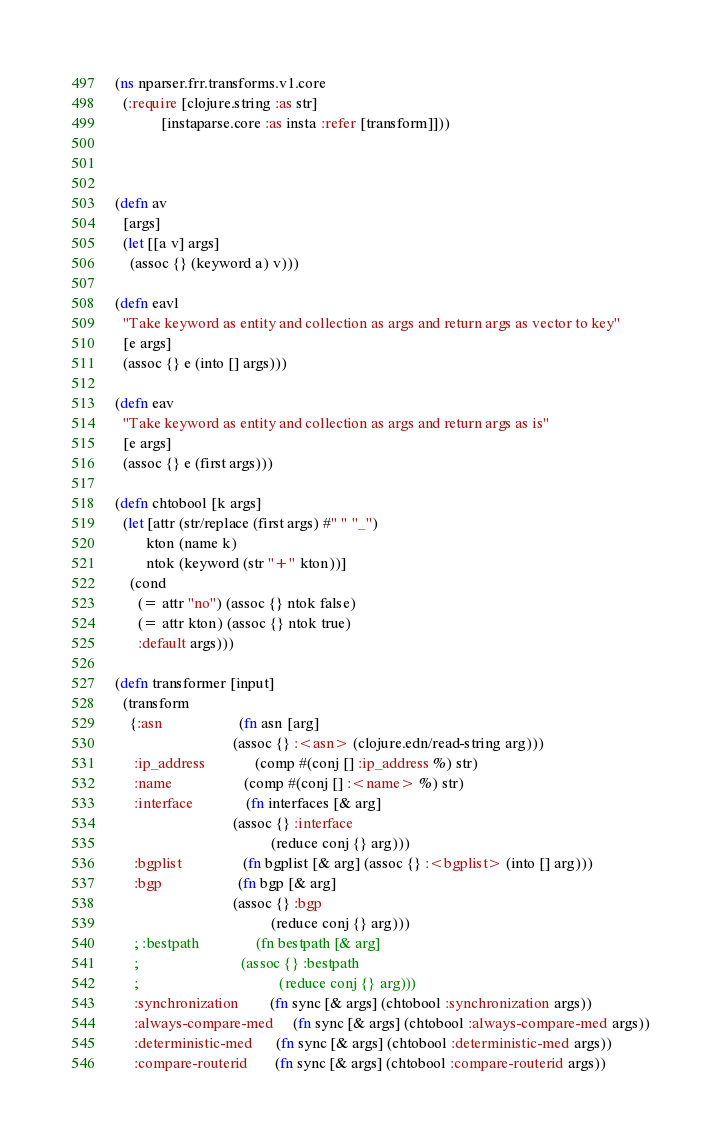Convert code to text. <code><loc_0><loc_0><loc_500><loc_500><_Clojure_>(ns nparser.frr.transforms.v1.core
  (:require [clojure.string :as str]
            [instaparse.core :as insta :refer [transform]]))



(defn av
  [args]
  (let [[a v] args]
    (assoc {} (keyword a) v)))

(defn eavl
  "Take keyword as entity and collection as args and return args as vector to key"
  [e args]
  (assoc {} e (into [] args)))

(defn eav
  "Take keyword as entity and collection as args and return args as is"
  [e args]
  (assoc {} e (first args)))

(defn chtobool [k args]
  (let [attr (str/replace (first args) #" " "_")
        kton (name k)
        ntok (keyword (str "+" kton))]
    (cond
      (= attr "no") (assoc {} ntok false)
      (= attr kton) (assoc {} ntok true)
      :default args)))

(defn transformer [input]
  (transform
    {:asn                    (fn asn [arg]
                               (assoc {} :<asn> (clojure.edn/read-string arg)))
     :ip_address             (comp #(conj [] :ip_address %) str)
     :name                   (comp #(conj [] :<name> %) str)
     :interface              (fn interfaces [& arg]
                               (assoc {} :interface
                                         (reduce conj {} arg)))
     :bgplist                (fn bgplist [& arg] (assoc {} :<bgplist> (into [] arg)))
     :bgp                    (fn bgp [& arg]
                               (assoc {} :bgp
                                         (reduce conj {} arg)))
     ; :bestpath               (fn bestpath [& arg]
     ;                           (assoc {} :bestpath
     ;                                     (reduce conj {} arg)))
     :synchronization        (fn sync [& args] (chtobool :synchronization args))
     :always-compare-med     (fn sync [& args] (chtobool :always-compare-med args))
     :deterministic-med      (fn sync [& args] (chtobool :deterministic-med args))
     :compare-routerid       (fn sync [& args] (chtobool :compare-routerid args))</code> 